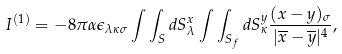<formula> <loc_0><loc_0><loc_500><loc_500>I ^ { ( 1 ) } = - 8 \pi \alpha \epsilon _ { \lambda \kappa \sigma } \int \int _ { S } d S _ { \lambda } ^ { x } \int \int _ { S _ { f } } d S _ { \kappa } ^ { y } \frac { ( x - y ) _ { \sigma } } { | \overline { x } - \overline { y } | ^ { 4 } } ,</formula> 